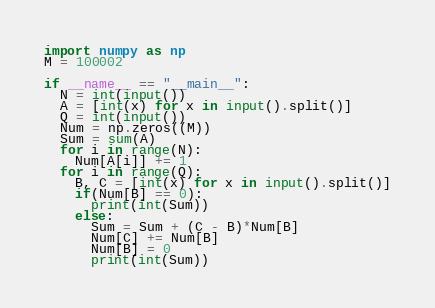<code> <loc_0><loc_0><loc_500><loc_500><_Python_>import numpy as np
M = 100002

if __name__ == "__main__":
  N = int(input())
  A = [int(x) for x in input().split()]
  Q = int(input())
  Num = np.zeros((M))
  Sum = sum(A)
  for i in range(N):
    Num[A[i]] += 1
  for i in range(Q):
    B, C = [int(x) for x in input().split()]
    if(Num[B] == 0):
      print(int(Sum))
    else:
      Sum = Sum + (C - B)*Num[B]
      Num[C] += Num[B]
      Num[B] = 0
      print(int(Sum))</code> 